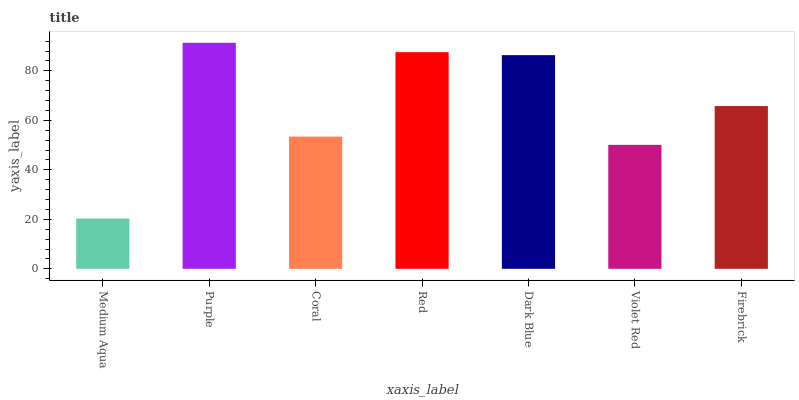Is Medium Aqua the minimum?
Answer yes or no. Yes. Is Purple the maximum?
Answer yes or no. Yes. Is Coral the minimum?
Answer yes or no. No. Is Coral the maximum?
Answer yes or no. No. Is Purple greater than Coral?
Answer yes or no. Yes. Is Coral less than Purple?
Answer yes or no. Yes. Is Coral greater than Purple?
Answer yes or no. No. Is Purple less than Coral?
Answer yes or no. No. Is Firebrick the high median?
Answer yes or no. Yes. Is Firebrick the low median?
Answer yes or no. Yes. Is Violet Red the high median?
Answer yes or no. No. Is Dark Blue the low median?
Answer yes or no. No. 